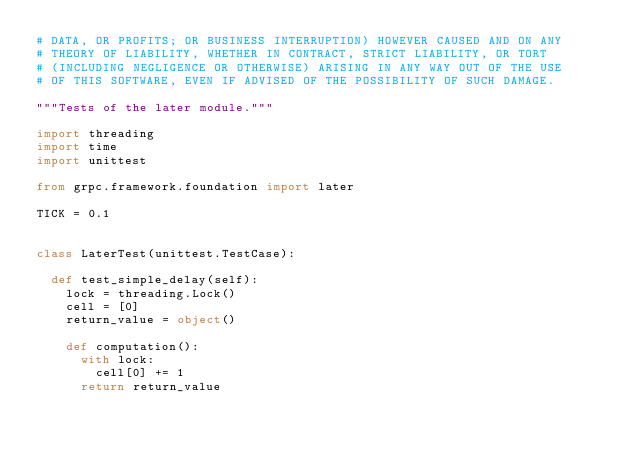<code> <loc_0><loc_0><loc_500><loc_500><_Python_># DATA, OR PROFITS; OR BUSINESS INTERRUPTION) HOWEVER CAUSED AND ON ANY
# THEORY OF LIABILITY, WHETHER IN CONTRACT, STRICT LIABILITY, OR TORT
# (INCLUDING NEGLIGENCE OR OTHERWISE) ARISING IN ANY WAY OUT OF THE USE
# OF THIS SOFTWARE, EVEN IF ADVISED OF THE POSSIBILITY OF SUCH DAMAGE.

"""Tests of the later module."""

import threading
import time
import unittest

from grpc.framework.foundation import later

TICK = 0.1


class LaterTest(unittest.TestCase):

  def test_simple_delay(self):
    lock = threading.Lock()
    cell = [0]
    return_value = object()

    def computation():
      with lock:
        cell[0] += 1
      return return_value</code> 